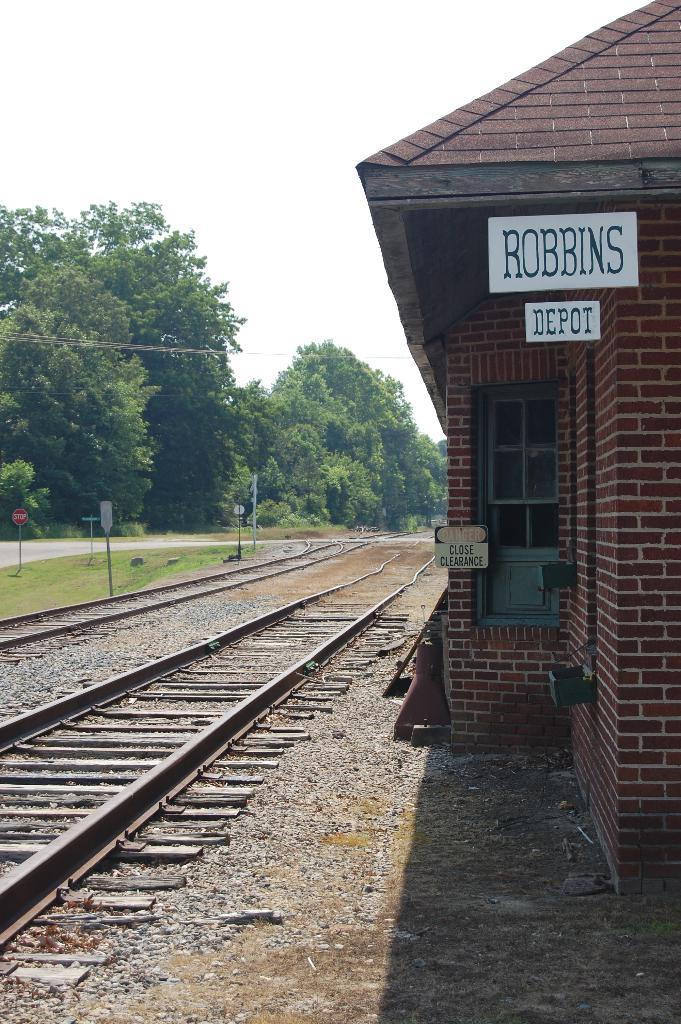What type of transportation infrastructure is present in the image? There is a railway track in the image. What type of building can be seen in the image? There is a house in the image. What structures are supporting the railway track? There are poles in the image. What type of signage is present in the image? There are boards in the image. What type of vegetation is present in the image? There are trees and grass in the image. What is visible in the background of the image? The sky is visible in the background of the image. What type of tank can be seen in the image? There is no tank or any other type of vehicle present in the image. Can you see a car driving on the railway track in the image? No, there is no car visible in the image. 